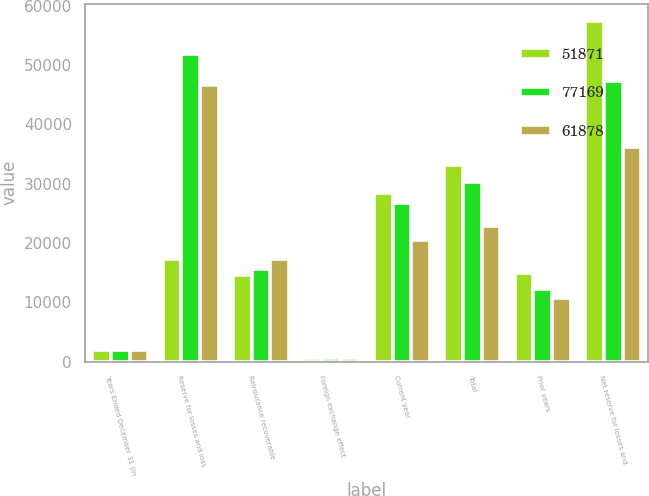Convert chart to OTSL. <chart><loc_0><loc_0><loc_500><loc_500><stacked_bar_chart><ecel><fcel>Years Ended December 31 (in<fcel>Reserve for losses and loss<fcel>Reinsurance recoverable<fcel>Foreign exchange effect<fcel>Current year<fcel>Total<fcel>Prior years<fcel>Net reserve for losses and<nl><fcel>51871<fcel>2005<fcel>17327<fcel>14624<fcel>628<fcel>28426<fcel>33091<fcel>14910<fcel>57476<nl><fcel>77169<fcel>2004<fcel>51871<fcel>15643<fcel>524<fcel>26793<fcel>30357<fcel>12163<fcel>47254<nl><fcel>61878<fcel>2003<fcel>46674<fcel>17327<fcel>580<fcel>20509<fcel>22872<fcel>10775<fcel>36228<nl></chart> 